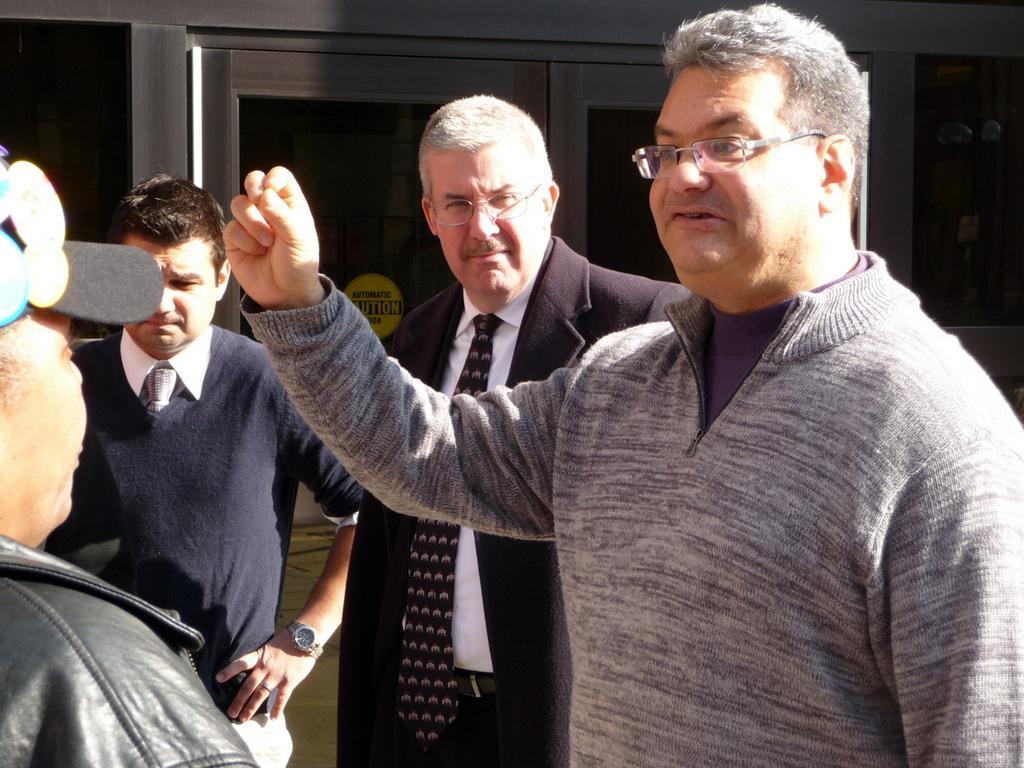Could you give a brief overview of what you see in this image? In this image we can see four people standing near the glass door, one yellow sticker with text attached to the glass door and one black poster attached to the wall. 